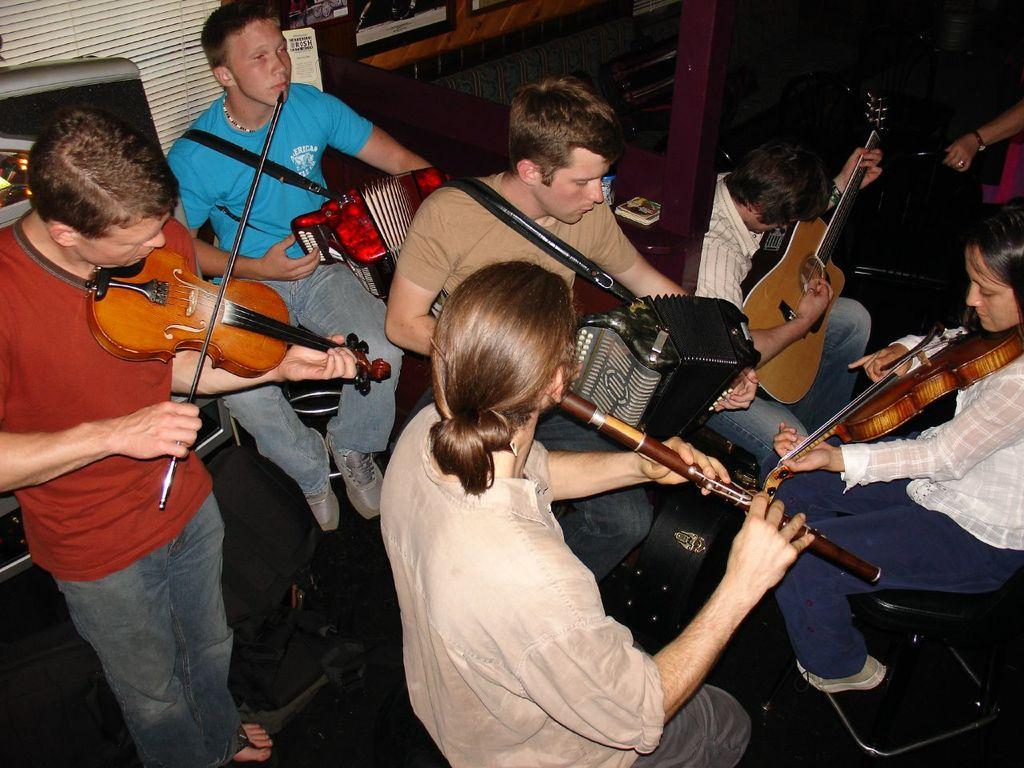What are the people in the image doing? The people in the image are playing musical instruments. Can you describe any objects or features visible behind the people playing musical instruments? Unfortunately, the provided facts do not give any specific details about the objects or features visible behind the people playing musical instruments. How many nuts are being used as percussion instruments by the people in the image? There are no nuts visible in the image, and the people are not using them as percussion instruments. Can you explain why the chickens are not playing musical instruments in the image? There are no chickens present in the image, so it is not possible to explain why they are not playing musical instruments. 